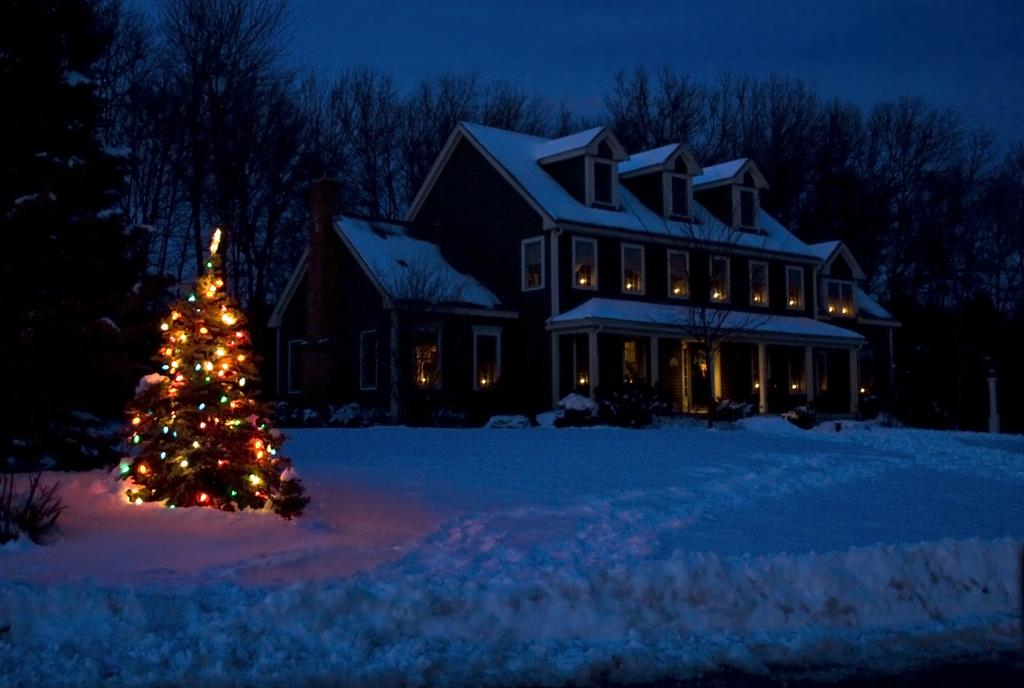What type of structure is present in the picture? There is a building in the picture. What season might the picture be depicting? The presence of a Christmas tree, snow, and lights suggests that the picture is set during the winter season. How is the Christmas tree decorated? The Christmas tree is decorated with lights. What can be seen in the background of the picture? There are trees, the sky, snow, and other objects in the background of the picture. Can you tell me how many owls are sitting on the seat in the picture? There are no owls or seats present in the image. What type of oil is being used to light the Christmas tree in the picture? The image does not show any oil being used to light the Christmas tree; it is decorated with lights. 